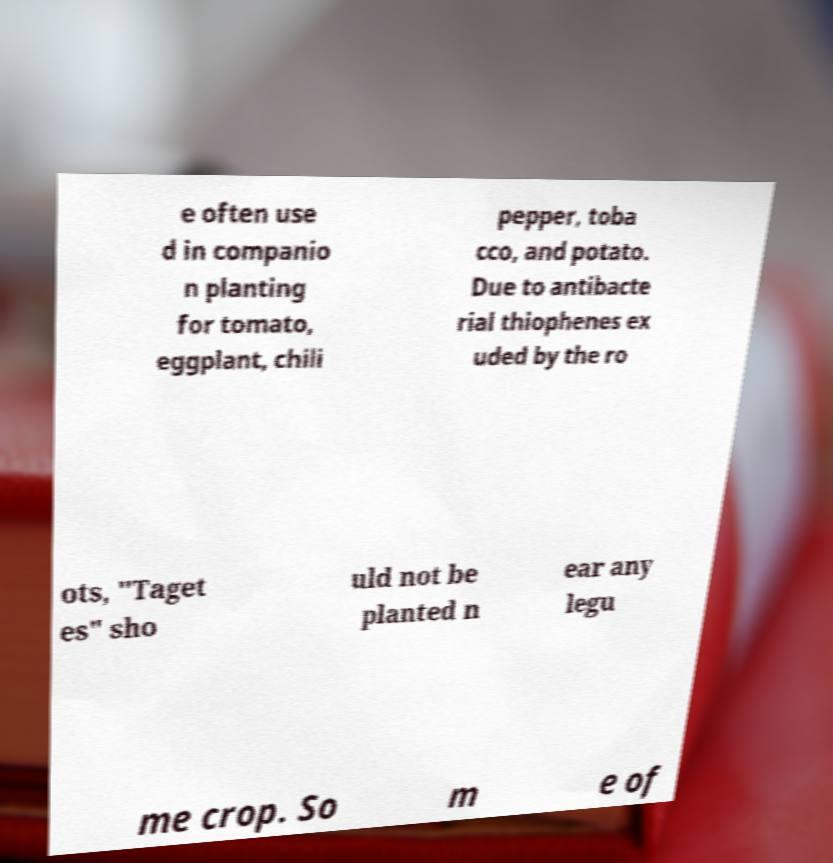Can you read and provide the text displayed in the image?This photo seems to have some interesting text. Can you extract and type it out for me? e often use d in companio n planting for tomato, eggplant, chili pepper, toba cco, and potato. Due to antibacte rial thiophenes ex uded by the ro ots, "Taget es" sho uld not be planted n ear any legu me crop. So m e of 